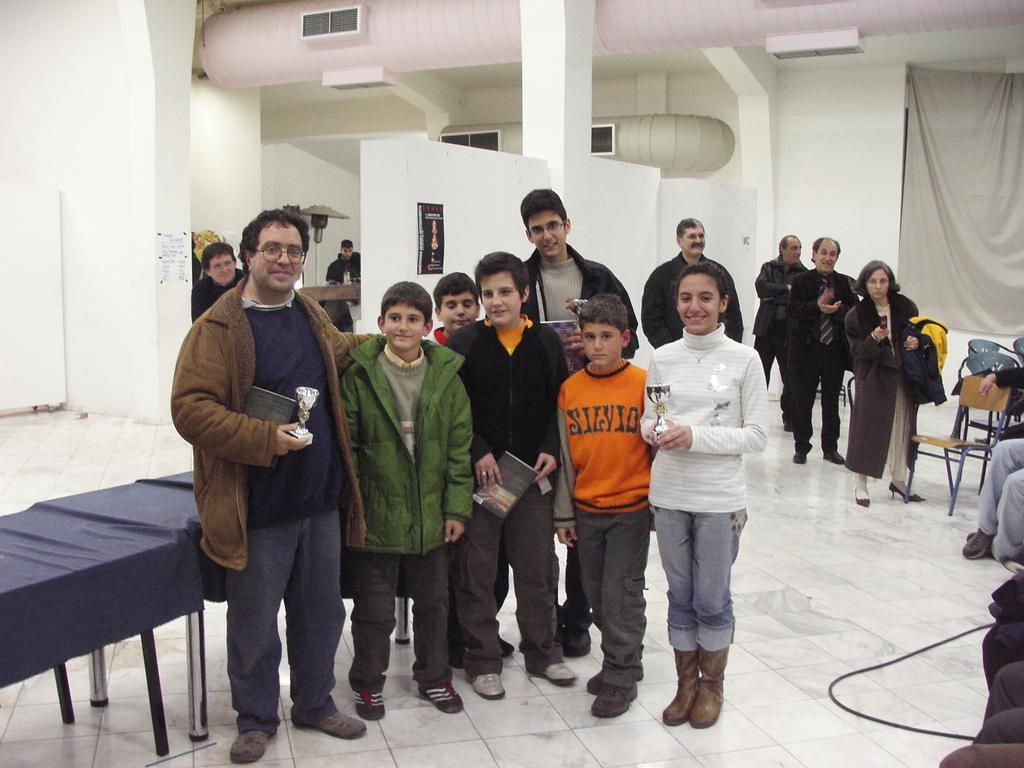Please provide a concise description of this image. In this image we can see men, women and children are standing on the white color floor. We can see chairs on the right side of the image and in the background, we can see one curtain and white color wall. There are tables on the left side of the image. 